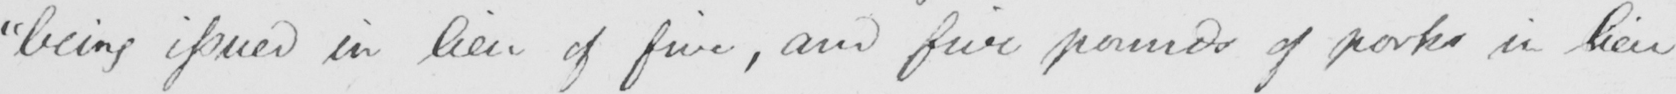Transcribe the text shown in this historical manuscript line. " being issued in lieu of five , and five pounds of port in lieu 